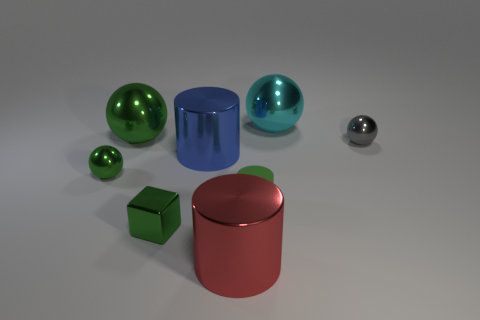There is a red object that is the same shape as the blue metallic thing; what size is it?
Offer a terse response. Large. What number of big objects are gray balls or matte spheres?
Your response must be concise. 0. Is the material of the big thing that is on the right side of the big red thing the same as the green object that is to the right of the blue metal cylinder?
Your response must be concise. No. There is a thing that is right of the big cyan thing; what is it made of?
Your answer should be compact. Metal. What number of shiny things are small blue objects or big red things?
Ensure brevity in your answer.  1. There is a small sphere on the right side of the large object behind the large green shiny ball; what color is it?
Give a very brief answer. Gray. Does the blue cylinder have the same material as the tiny green thing on the right side of the small green shiny cube?
Give a very brief answer. No. There is a small shiny object that is right of the green metal object that is in front of the green sphere in front of the small gray thing; what color is it?
Your response must be concise. Gray. Are there more cylinders than large gray metallic blocks?
Make the answer very short. Yes. How many objects are both behind the small gray shiny ball and to the left of the blue metallic object?
Offer a very short reply. 1. 